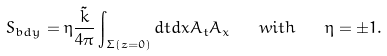Convert formula to latex. <formula><loc_0><loc_0><loc_500><loc_500>S _ { b d y } = \eta \frac { \tilde { k } } { 4 \pi } \int _ { \Sigma ( z = 0 ) } d t d x A _ { t } A _ { x } \quad w i t h \quad \eta = \pm 1 .</formula> 